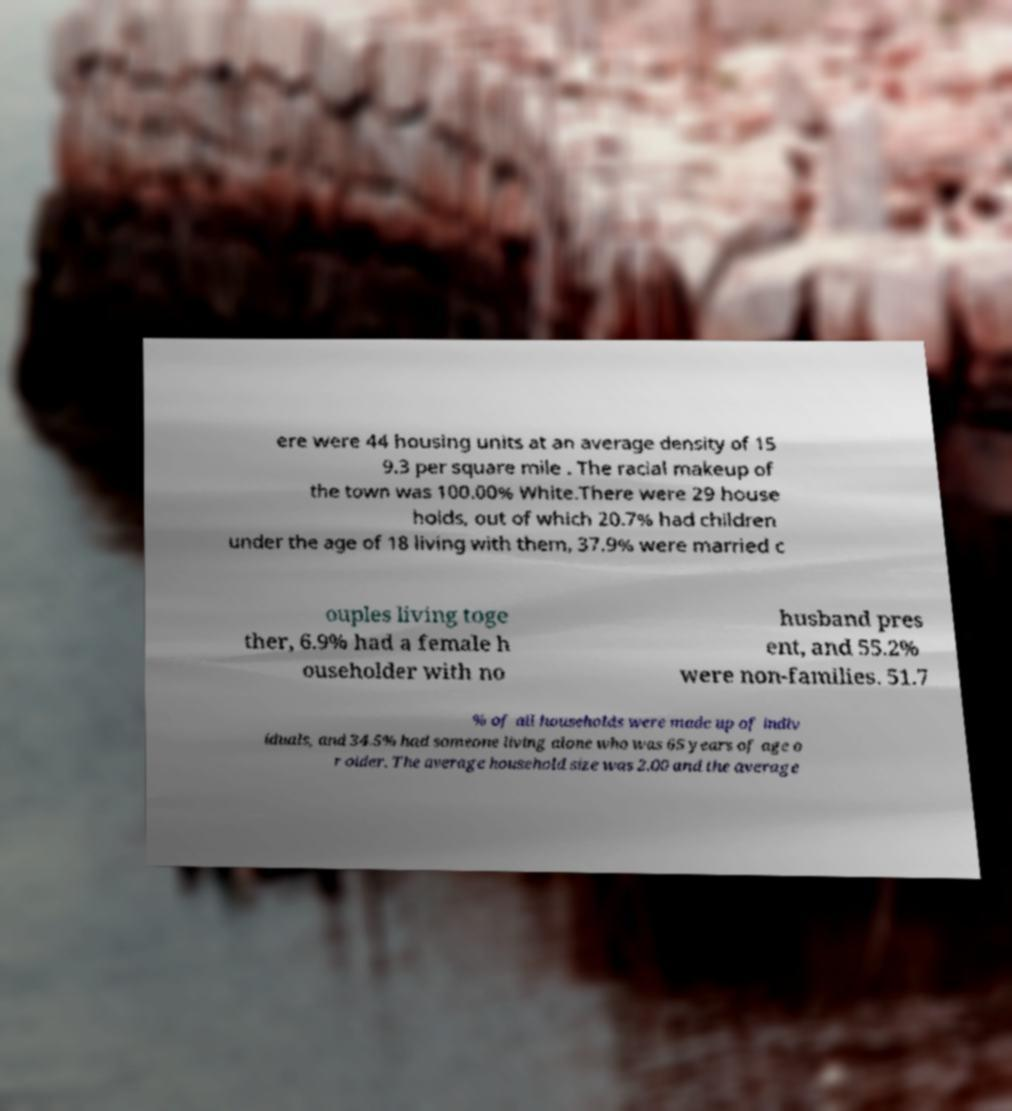Can you read and provide the text displayed in the image?This photo seems to have some interesting text. Can you extract and type it out for me? ere were 44 housing units at an average density of 15 9.3 per square mile . The racial makeup of the town was 100.00% White.There were 29 house holds, out of which 20.7% had children under the age of 18 living with them, 37.9% were married c ouples living toge ther, 6.9% had a female h ouseholder with no husband pres ent, and 55.2% were non-families. 51.7 % of all households were made up of indiv iduals, and 34.5% had someone living alone who was 65 years of age o r older. The average household size was 2.00 and the average 